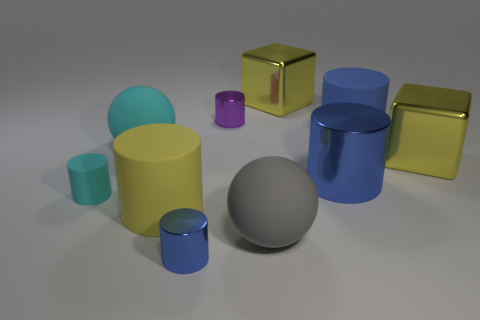Are there any blue objects of the same shape as the tiny cyan object?
Offer a terse response. Yes. Is the size of the cyan rubber thing in front of the cyan ball the same as the big gray thing?
Offer a terse response. No. Is there a metallic cylinder?
Your response must be concise. Yes. What number of things are large matte cylinders on the right side of the tiny blue shiny object or tiny cyan rubber spheres?
Give a very brief answer. 1. Do the small matte cylinder and the big ball behind the small cyan cylinder have the same color?
Your answer should be very brief. Yes. Are there any yellow metal objects of the same size as the yellow rubber cylinder?
Your answer should be very brief. Yes. What is the material of the large yellow object that is to the left of the large sphere to the right of the tiny purple cylinder?
Offer a very short reply. Rubber. How many large balls are the same color as the big metal cylinder?
Provide a succinct answer. 0. There is a cyan thing that is the same material as the small cyan cylinder; what is its shape?
Offer a very short reply. Sphere. What is the size of the cylinder behind the big blue matte thing?
Your response must be concise. Small. 